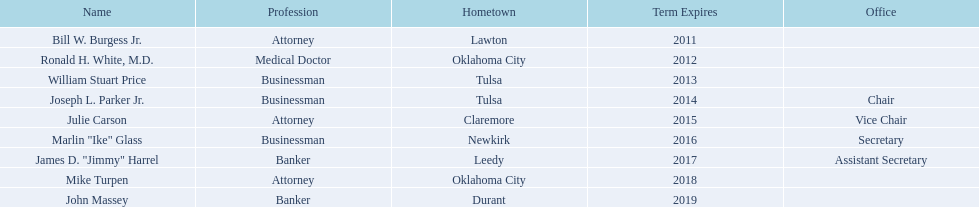What businessmen were born in tulsa? William Stuart Price, Joseph L. Parker Jr. Which man, other than price, was born in tulsa? Joseph L. Parker Jr. 